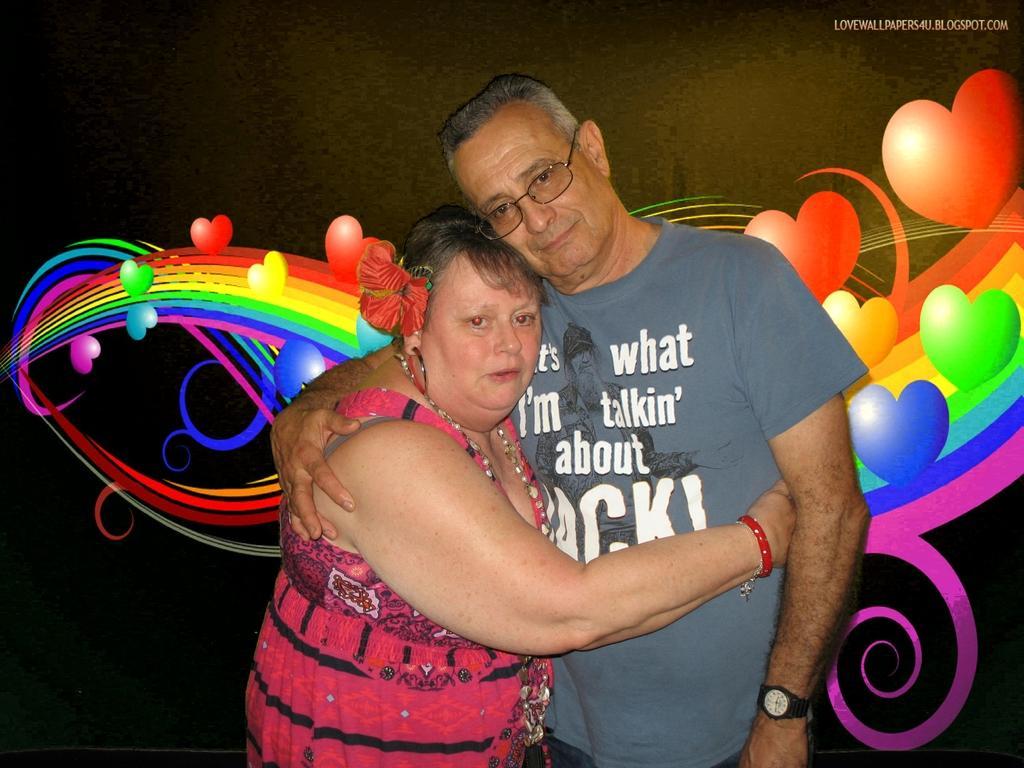How would you summarize this image in a sentence or two? In This image in the center there is one man and one woman standing, and they are hugging each other. And in the background it looks like an art, and at the top of the image there is text. 